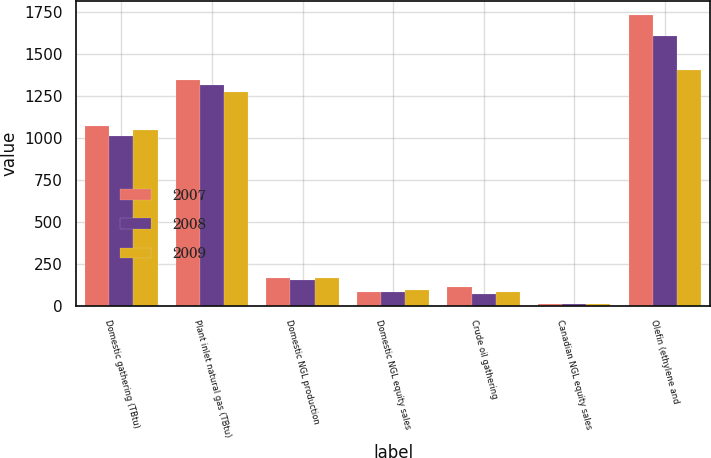Convert chart to OTSL. <chart><loc_0><loc_0><loc_500><loc_500><stacked_bar_chart><ecel><fcel>Domestic gathering (TBtu)<fcel>Plant inlet natural gas (TBtu)<fcel>Domestic NGL production<fcel>Domestic NGL equity sales<fcel>Crude oil gathering<fcel>Canadian NGL equity sales<fcel>Olefin (ethylene and<nl><fcel>2007<fcel>1068<fcel>1342<fcel>164<fcel>80<fcel>109<fcel>8<fcel>1728<nl><fcel>2008<fcel>1013<fcel>1311<fcel>154<fcel>80<fcel>70<fcel>7<fcel>1605<nl><fcel>2009<fcel>1045<fcel>1275<fcel>163<fcel>92<fcel>80<fcel>9<fcel>1401<nl></chart> 